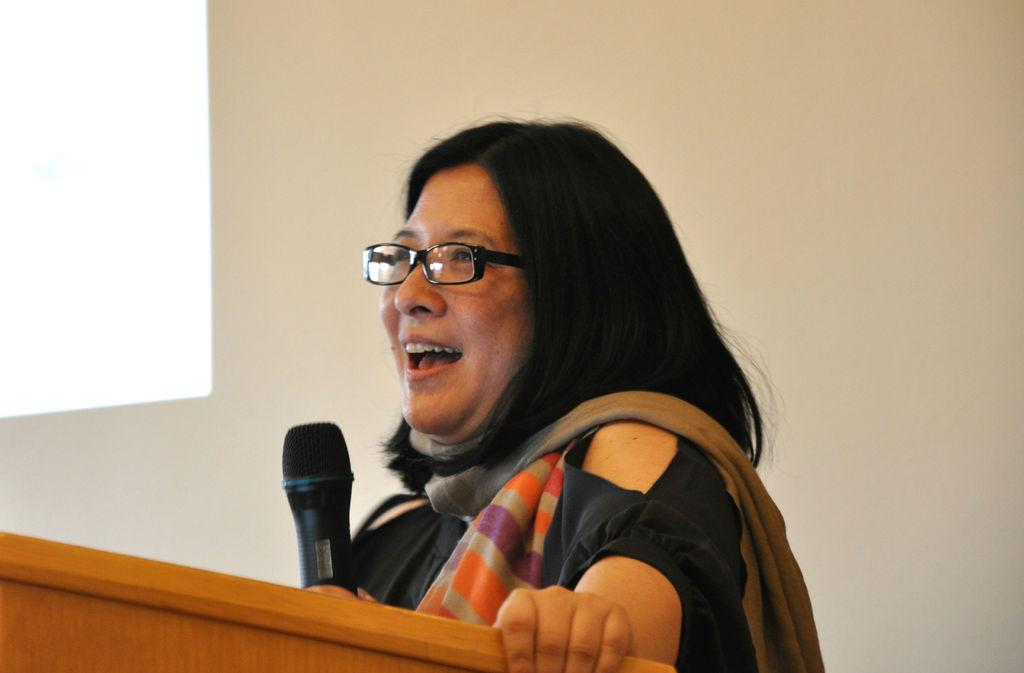Who is the main subject in the image? There is a woman in the image. Where is the woman positioned in the image? The woman is standing in the center of the image. What is the woman doing in the image? The woman is speaking and smiling. What object is the woman holding in her hand? The woman is holding a mic in her hand. What can be seen in the front of the image? There is a wooden stand in the front of the image. What is the woman's tendency to lip sync in the image? There is no mention of lip syncing in the image, and the woman is holding a mic, which suggests she is speaking. 